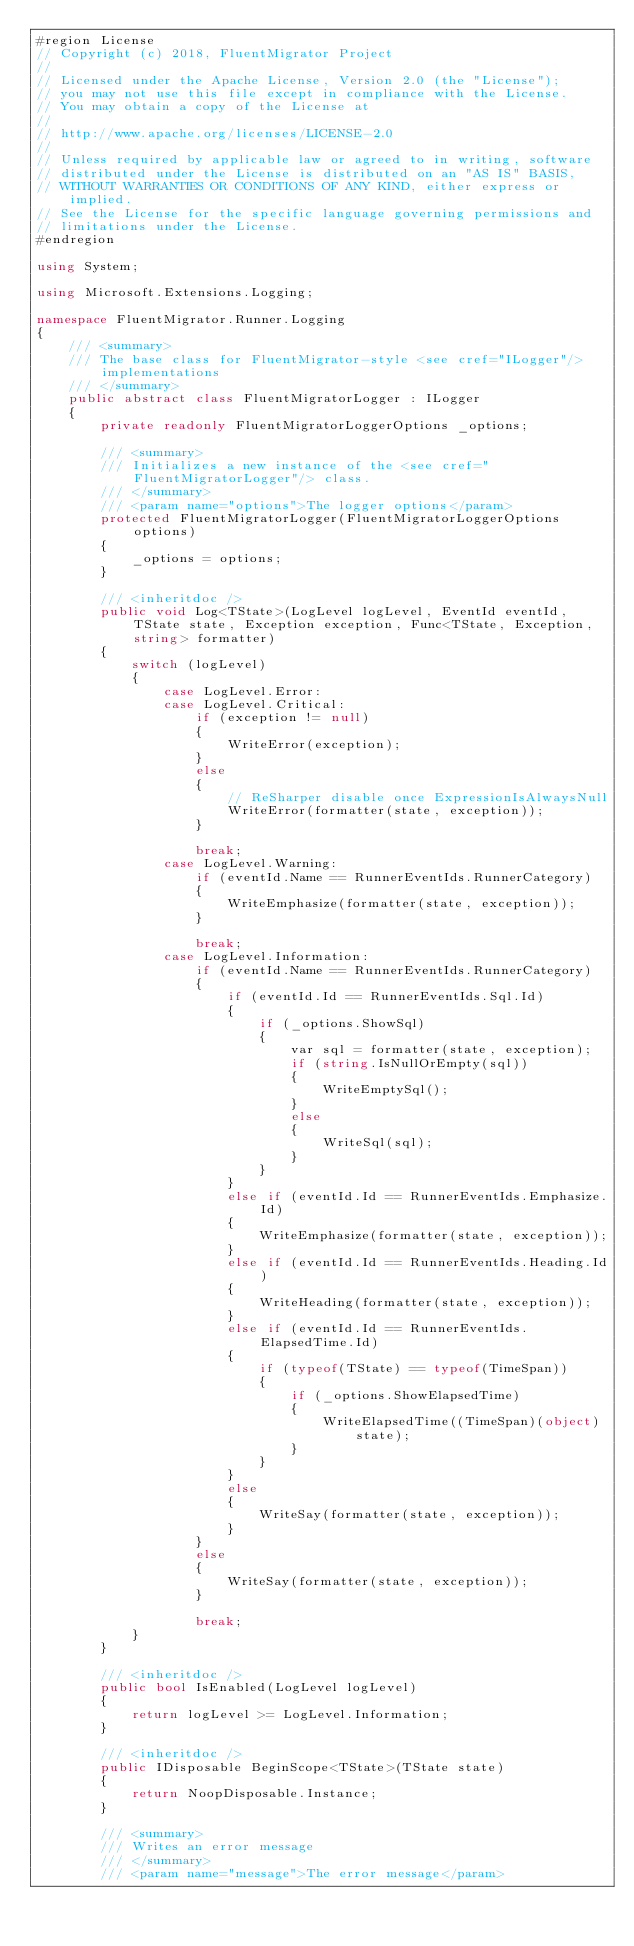Convert code to text. <code><loc_0><loc_0><loc_500><loc_500><_C#_>#region License
// Copyright (c) 2018, FluentMigrator Project
//
// Licensed under the Apache License, Version 2.0 (the "License");
// you may not use this file except in compliance with the License.
// You may obtain a copy of the License at
//
// http://www.apache.org/licenses/LICENSE-2.0
//
// Unless required by applicable law or agreed to in writing, software
// distributed under the License is distributed on an "AS IS" BASIS,
// WITHOUT WARRANTIES OR CONDITIONS OF ANY KIND, either express or implied.
// See the License for the specific language governing permissions and
// limitations under the License.
#endregion

using System;

using Microsoft.Extensions.Logging;

namespace FluentMigrator.Runner.Logging
{
    /// <summary>
    /// The base class for FluentMigrator-style <see cref="ILogger"/> implementations
    /// </summary>
    public abstract class FluentMigratorLogger : ILogger
    {
        private readonly FluentMigratorLoggerOptions _options;

        /// <summary>
        /// Initializes a new instance of the <see cref="FluentMigratorLogger"/> class.
        /// </summary>
        /// <param name="options">The logger options</param>
        protected FluentMigratorLogger(FluentMigratorLoggerOptions options)
        {
            _options = options;
        }

        /// <inheritdoc />
        public void Log<TState>(LogLevel logLevel, EventId eventId, TState state, Exception exception, Func<TState, Exception, string> formatter)
        {
            switch (logLevel)
            {
                case LogLevel.Error:
                case LogLevel.Critical:
                    if (exception != null)
                    {
                        WriteError(exception);
                    }
                    else
                    {
                        // ReSharper disable once ExpressionIsAlwaysNull
                        WriteError(formatter(state, exception));
                    }

                    break;
                case LogLevel.Warning:
                    if (eventId.Name == RunnerEventIds.RunnerCategory)
                    {
                        WriteEmphasize(formatter(state, exception));
                    }

                    break;
                case LogLevel.Information:
                    if (eventId.Name == RunnerEventIds.RunnerCategory)
                    {
                        if (eventId.Id == RunnerEventIds.Sql.Id)
                        {
                            if (_options.ShowSql)
                            {
                                var sql = formatter(state, exception);
                                if (string.IsNullOrEmpty(sql))
                                {
                                    WriteEmptySql();
                                }
                                else
                                {
                                    WriteSql(sql);
                                }
                            }
                        }
                        else if (eventId.Id == RunnerEventIds.Emphasize.Id)
                        {
                            WriteEmphasize(formatter(state, exception));
                        }
                        else if (eventId.Id == RunnerEventIds.Heading.Id)
                        {
                            WriteHeading(formatter(state, exception));
                        }
                        else if (eventId.Id == RunnerEventIds.ElapsedTime.Id)
                        {
                            if (typeof(TState) == typeof(TimeSpan))
                            {
                                if (_options.ShowElapsedTime)
                                {
                                    WriteElapsedTime((TimeSpan)(object)state);
                                }
                            }
                        }
                        else
                        {
                            WriteSay(formatter(state, exception));
                        }
                    }
                    else
                    {
                        WriteSay(formatter(state, exception));
                    }

                    break;
            }
        }

        /// <inheritdoc />
        public bool IsEnabled(LogLevel logLevel)
        {
            return logLevel >= LogLevel.Information;
        }

        /// <inheritdoc />
        public IDisposable BeginScope<TState>(TState state)
        {
            return NoopDisposable.Instance;
        }

        /// <summary>
        /// Writes an error message
        /// </summary>
        /// <param name="message">The error message</param></code> 